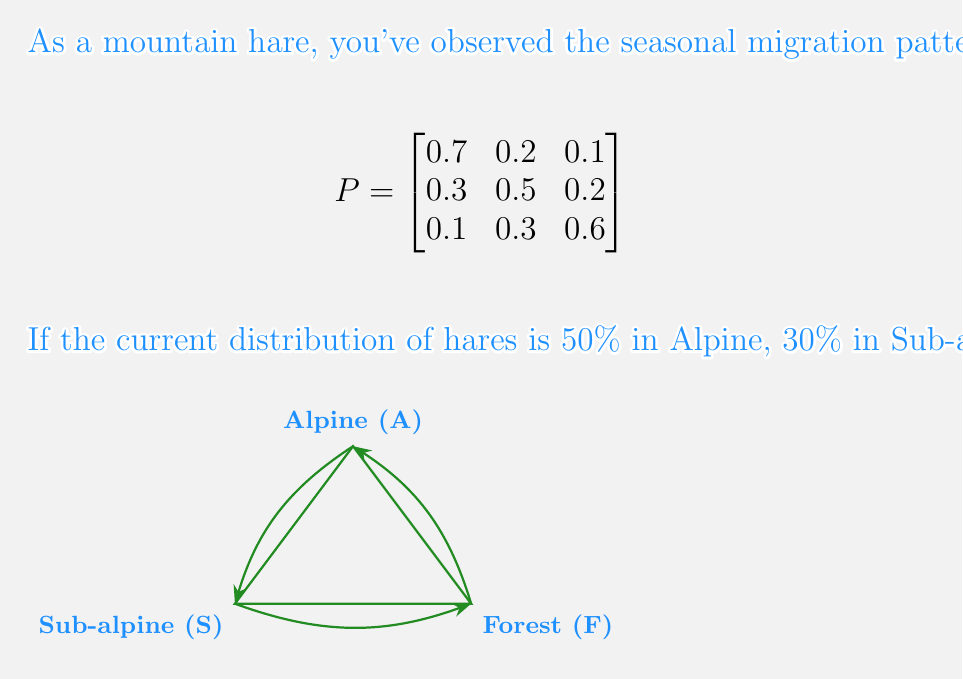Solve this math problem. Let's approach this step-by-step:

1) First, we need to represent the current distribution as a row vector:
   $$v_0 = \begin{bmatrix} 0.5 & 0.3 & 0.2 \end{bmatrix}$$

2) To find the distribution after two seasons, we need to multiply this vector by the transition matrix twice:
   $$v_2 = v_0 \cdot P^2$$

3) Let's calculate $P^2$ first:
   $$P^2 = P \cdot P = \begin{bmatrix}
   0.7 & 0.2 & 0.1 \\
   0.3 & 0.5 & 0.2 \\
   0.1 & 0.3 & 0.6
   \end{bmatrix} \cdot \begin{bmatrix}
   0.7 & 0.2 & 0.1 \\
   0.3 & 0.5 & 0.2 \\
   0.1 & 0.3 & 0.6
   \end{bmatrix}$$

4) Multiplying these matrices:
   $$P^2 = \begin{bmatrix}
   0.58 & 0.27 & 0.15 \\
   0.43 & 0.37 & 0.20 \\
   0.22 & 0.36 & 0.42
   \end{bmatrix}$$

5) Now, we multiply $v_0$ by $P^2$:
   $$v_2 = \begin{bmatrix} 0.5 & 0.3 & 0.2 \end{bmatrix} \cdot \begin{bmatrix}
   0.58 & 0.27 & 0.15 \\
   0.43 & 0.37 & 0.20 \\
   0.22 & 0.36 & 0.42
   \end{bmatrix}$$

6) Calculating this multiplication:
   $$v_2 = \begin{bmatrix} 0.4735 & 0.3105 & 0.2160 \end{bmatrix}$$

7) Rounding to the nearest percent:
   $$v_2 \approx \begin{bmatrix} 47\% & 31\% & 22\% \end{bmatrix}$$

Therefore, after two seasons, approximately 47% of hares will be in Alpine habitats, 31% in Sub-alpine habitats, and 22% in Forest habitats.
Answer: 47% Alpine, 31% Sub-alpine, 22% Forest 